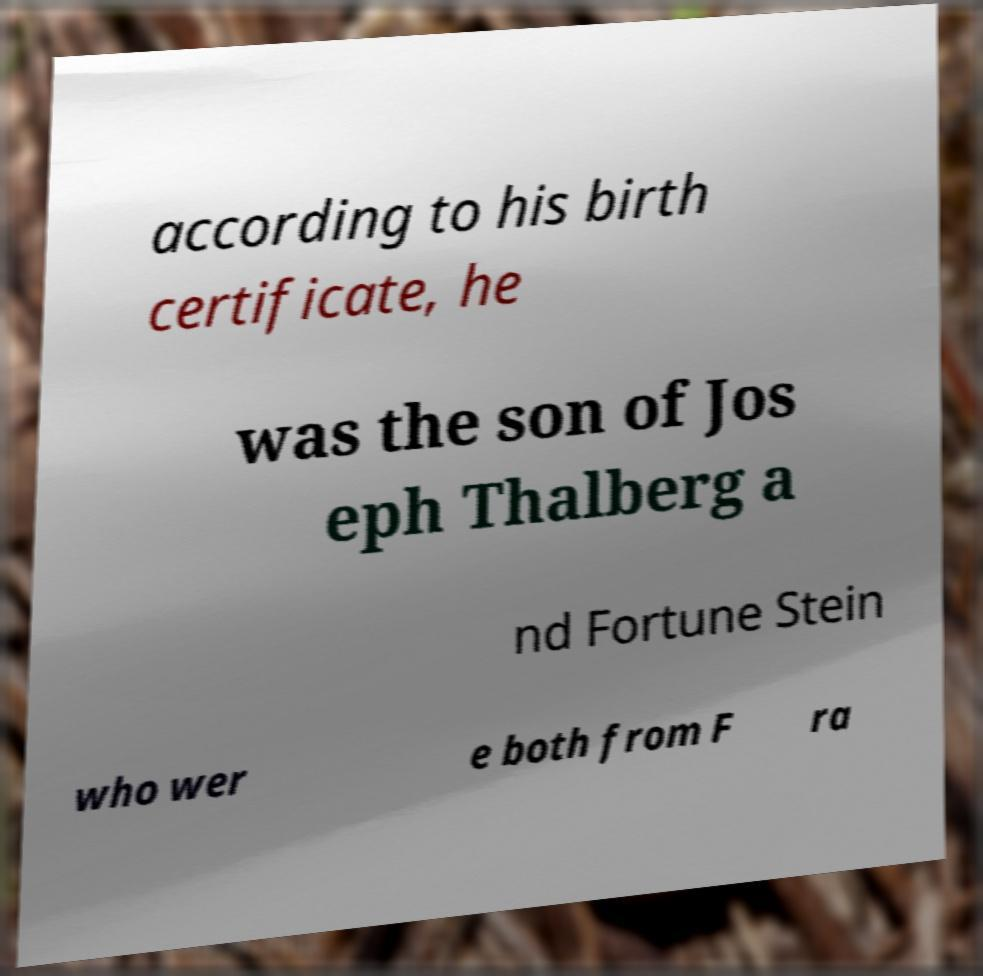What messages or text are displayed in this image? I need them in a readable, typed format. according to his birth certificate, he was the son of Jos eph Thalberg a nd Fortune Stein who wer e both from F ra 